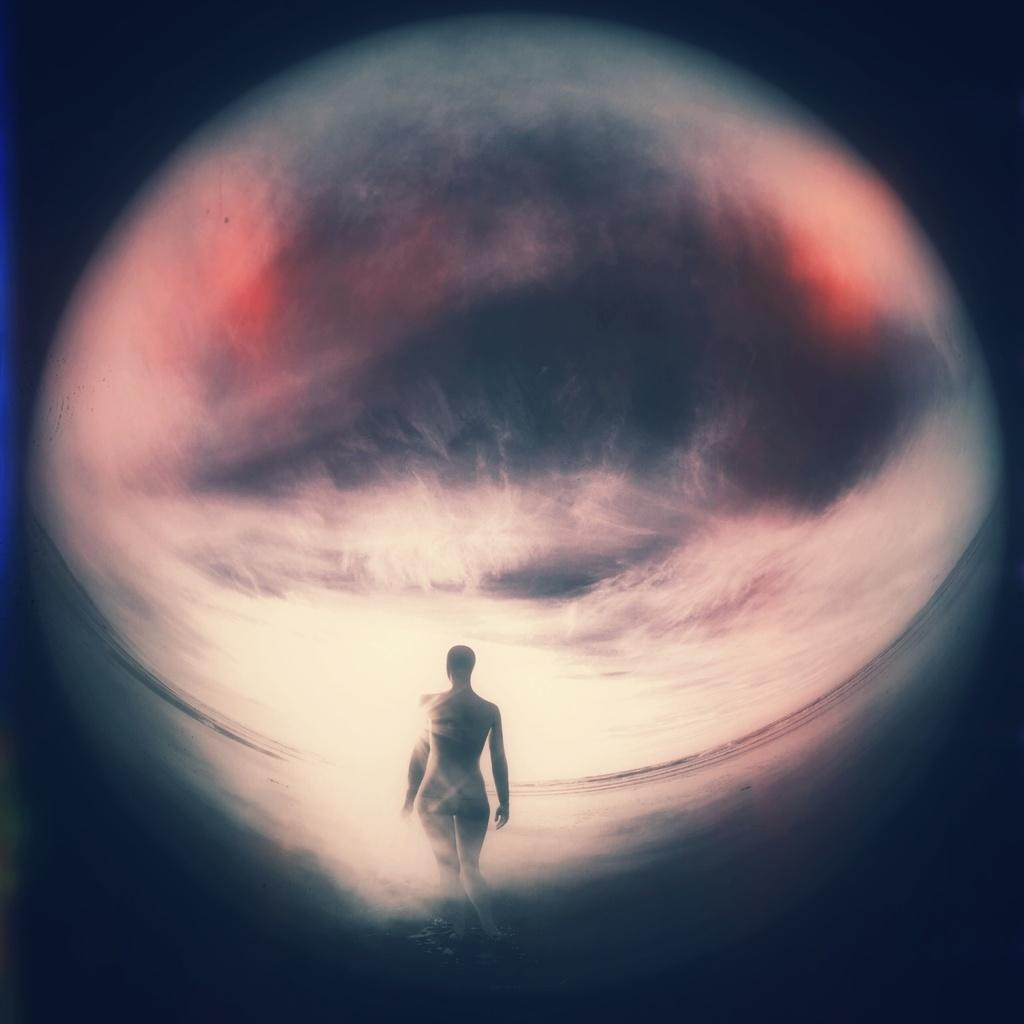What is the main subject of the image? There is a person in the image. Can you describe the background of the image? The background of the image contains blue, white, orange, and black colors. What type of magic is the person performing in the image? There is no indication of magic or any magical activity in the image. 